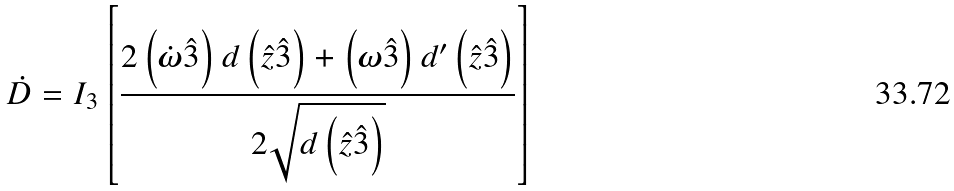<formula> <loc_0><loc_0><loc_500><loc_500>\dot { D } = I _ { 3 } \left [ \frac { 2 \left ( \dot { \boldsymbol \omega } \hat { 3 } \right ) d \left ( \hat { z } \hat { 3 } \right ) + \left ( \boldsymbol \omega \hat { 3 } \right ) d ^ { \prime } \left ( \hat { z } \hat { 3 } \right ) } { 2 \sqrt { d \left ( \hat { z } \hat { 3 } \right ) } } \right ]</formula> 